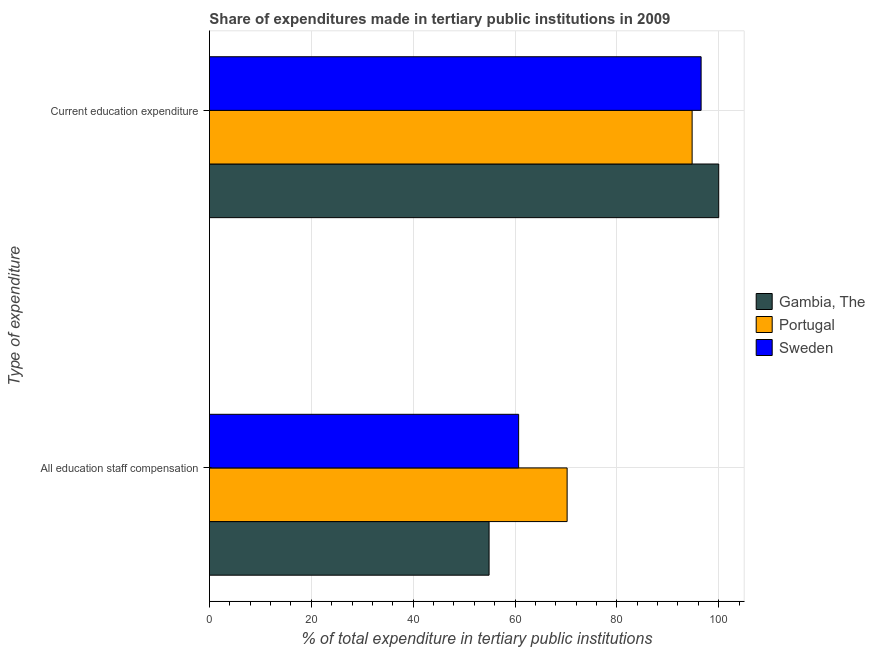How many different coloured bars are there?
Provide a succinct answer. 3. Are the number of bars per tick equal to the number of legend labels?
Provide a succinct answer. Yes. How many bars are there on the 1st tick from the top?
Your answer should be compact. 3. What is the label of the 1st group of bars from the top?
Ensure brevity in your answer.  Current education expenditure. What is the expenditure in education in Sweden?
Give a very brief answer. 96.54. Across all countries, what is the maximum expenditure in staff compensation?
Offer a very short reply. 70.24. Across all countries, what is the minimum expenditure in staff compensation?
Your answer should be very brief. 54.91. In which country was the expenditure in staff compensation maximum?
Offer a very short reply. Portugal. What is the total expenditure in staff compensation in the graph?
Your answer should be compact. 185.86. What is the difference between the expenditure in education in Gambia, The and that in Portugal?
Offer a very short reply. 5.22. What is the difference between the expenditure in education in Portugal and the expenditure in staff compensation in Gambia, The?
Offer a very short reply. 39.87. What is the average expenditure in education per country?
Give a very brief answer. 97.11. What is the difference between the expenditure in education and expenditure in staff compensation in Portugal?
Provide a short and direct response. 24.54. In how many countries, is the expenditure in education greater than 44 %?
Offer a very short reply. 3. What is the ratio of the expenditure in education in Sweden to that in Portugal?
Offer a terse response. 1.02. In how many countries, is the expenditure in staff compensation greater than the average expenditure in staff compensation taken over all countries?
Provide a succinct answer. 1. What does the 3rd bar from the top in All education staff compensation represents?
Your response must be concise. Gambia, The. What does the 1st bar from the bottom in Current education expenditure represents?
Your response must be concise. Gambia, The. Are the values on the major ticks of X-axis written in scientific E-notation?
Provide a short and direct response. No. Does the graph contain grids?
Offer a very short reply. Yes. Where does the legend appear in the graph?
Your answer should be compact. Center right. How are the legend labels stacked?
Offer a very short reply. Vertical. What is the title of the graph?
Provide a succinct answer. Share of expenditures made in tertiary public institutions in 2009. Does "Fragile and conflict affected situations" appear as one of the legend labels in the graph?
Ensure brevity in your answer.  No. What is the label or title of the X-axis?
Your response must be concise. % of total expenditure in tertiary public institutions. What is the label or title of the Y-axis?
Your response must be concise. Type of expenditure. What is the % of total expenditure in tertiary public institutions in Gambia, The in All education staff compensation?
Give a very brief answer. 54.91. What is the % of total expenditure in tertiary public institutions of Portugal in All education staff compensation?
Your answer should be very brief. 70.24. What is the % of total expenditure in tertiary public institutions of Sweden in All education staff compensation?
Your answer should be compact. 60.72. What is the % of total expenditure in tertiary public institutions of Portugal in Current education expenditure?
Provide a succinct answer. 94.78. What is the % of total expenditure in tertiary public institutions in Sweden in Current education expenditure?
Ensure brevity in your answer.  96.54. Across all Type of expenditure, what is the maximum % of total expenditure in tertiary public institutions of Gambia, The?
Ensure brevity in your answer.  100. Across all Type of expenditure, what is the maximum % of total expenditure in tertiary public institutions of Portugal?
Ensure brevity in your answer.  94.78. Across all Type of expenditure, what is the maximum % of total expenditure in tertiary public institutions in Sweden?
Keep it short and to the point. 96.54. Across all Type of expenditure, what is the minimum % of total expenditure in tertiary public institutions of Gambia, The?
Give a very brief answer. 54.91. Across all Type of expenditure, what is the minimum % of total expenditure in tertiary public institutions in Portugal?
Offer a terse response. 70.24. Across all Type of expenditure, what is the minimum % of total expenditure in tertiary public institutions in Sweden?
Your answer should be very brief. 60.72. What is the total % of total expenditure in tertiary public institutions of Gambia, The in the graph?
Ensure brevity in your answer.  154.91. What is the total % of total expenditure in tertiary public institutions of Portugal in the graph?
Offer a terse response. 165.02. What is the total % of total expenditure in tertiary public institutions in Sweden in the graph?
Your answer should be compact. 157.26. What is the difference between the % of total expenditure in tertiary public institutions of Gambia, The in All education staff compensation and that in Current education expenditure?
Your response must be concise. -45.09. What is the difference between the % of total expenditure in tertiary public institutions of Portugal in All education staff compensation and that in Current education expenditure?
Provide a succinct answer. -24.54. What is the difference between the % of total expenditure in tertiary public institutions of Sweden in All education staff compensation and that in Current education expenditure?
Your answer should be compact. -35.83. What is the difference between the % of total expenditure in tertiary public institutions of Gambia, The in All education staff compensation and the % of total expenditure in tertiary public institutions of Portugal in Current education expenditure?
Ensure brevity in your answer.  -39.87. What is the difference between the % of total expenditure in tertiary public institutions in Gambia, The in All education staff compensation and the % of total expenditure in tertiary public institutions in Sweden in Current education expenditure?
Provide a short and direct response. -41.63. What is the difference between the % of total expenditure in tertiary public institutions of Portugal in All education staff compensation and the % of total expenditure in tertiary public institutions of Sweden in Current education expenditure?
Provide a succinct answer. -26.31. What is the average % of total expenditure in tertiary public institutions of Gambia, The per Type of expenditure?
Make the answer very short. 77.46. What is the average % of total expenditure in tertiary public institutions in Portugal per Type of expenditure?
Offer a terse response. 82.51. What is the average % of total expenditure in tertiary public institutions of Sweden per Type of expenditure?
Provide a succinct answer. 78.63. What is the difference between the % of total expenditure in tertiary public institutions in Gambia, The and % of total expenditure in tertiary public institutions in Portugal in All education staff compensation?
Provide a succinct answer. -15.32. What is the difference between the % of total expenditure in tertiary public institutions in Gambia, The and % of total expenditure in tertiary public institutions in Sweden in All education staff compensation?
Your answer should be very brief. -5.8. What is the difference between the % of total expenditure in tertiary public institutions of Portugal and % of total expenditure in tertiary public institutions of Sweden in All education staff compensation?
Give a very brief answer. 9.52. What is the difference between the % of total expenditure in tertiary public institutions in Gambia, The and % of total expenditure in tertiary public institutions in Portugal in Current education expenditure?
Provide a succinct answer. 5.22. What is the difference between the % of total expenditure in tertiary public institutions in Gambia, The and % of total expenditure in tertiary public institutions in Sweden in Current education expenditure?
Provide a succinct answer. 3.46. What is the difference between the % of total expenditure in tertiary public institutions of Portugal and % of total expenditure in tertiary public institutions of Sweden in Current education expenditure?
Your answer should be compact. -1.76. What is the ratio of the % of total expenditure in tertiary public institutions in Gambia, The in All education staff compensation to that in Current education expenditure?
Keep it short and to the point. 0.55. What is the ratio of the % of total expenditure in tertiary public institutions in Portugal in All education staff compensation to that in Current education expenditure?
Your answer should be very brief. 0.74. What is the ratio of the % of total expenditure in tertiary public institutions of Sweden in All education staff compensation to that in Current education expenditure?
Offer a very short reply. 0.63. What is the difference between the highest and the second highest % of total expenditure in tertiary public institutions in Gambia, The?
Your response must be concise. 45.09. What is the difference between the highest and the second highest % of total expenditure in tertiary public institutions in Portugal?
Offer a very short reply. 24.54. What is the difference between the highest and the second highest % of total expenditure in tertiary public institutions of Sweden?
Make the answer very short. 35.83. What is the difference between the highest and the lowest % of total expenditure in tertiary public institutions in Gambia, The?
Your answer should be very brief. 45.09. What is the difference between the highest and the lowest % of total expenditure in tertiary public institutions in Portugal?
Offer a very short reply. 24.54. What is the difference between the highest and the lowest % of total expenditure in tertiary public institutions of Sweden?
Offer a terse response. 35.83. 